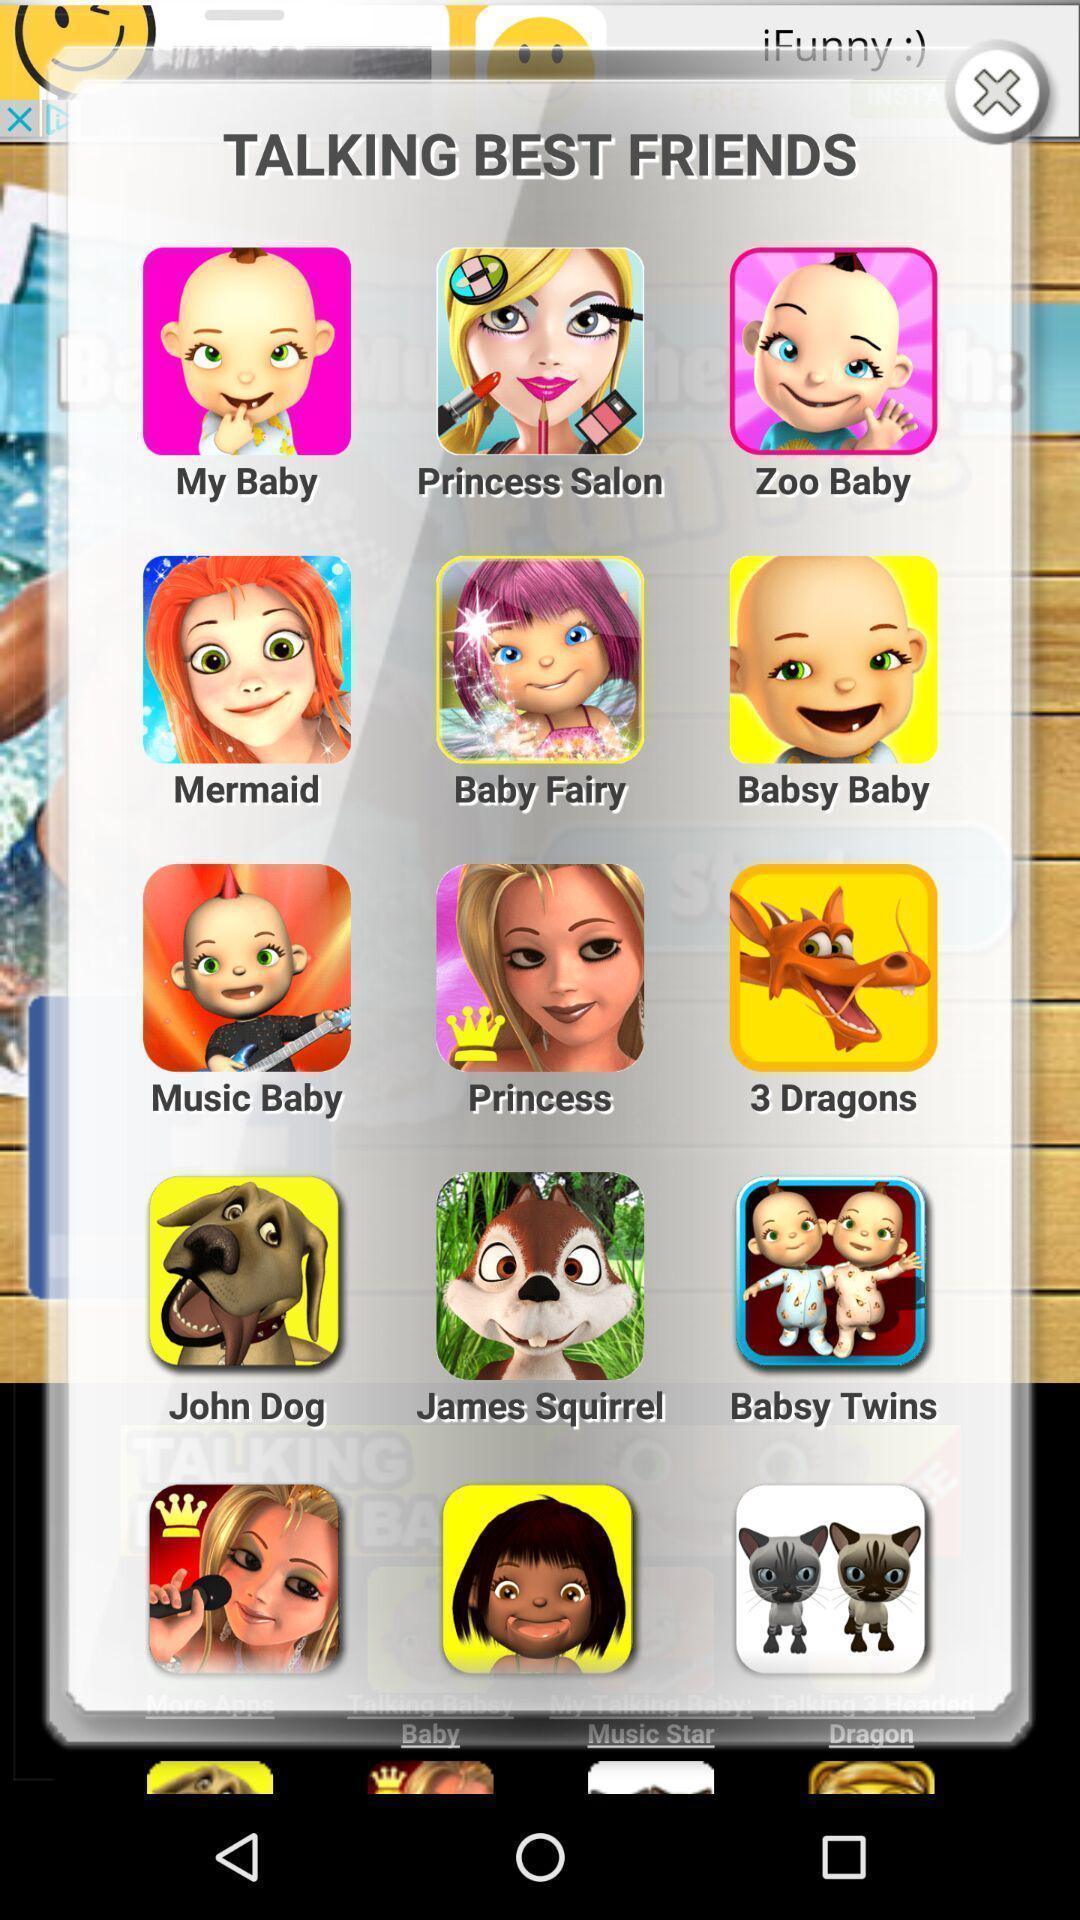Explain what's happening in this screen capture. Pop up of animated cartoon pictures. 